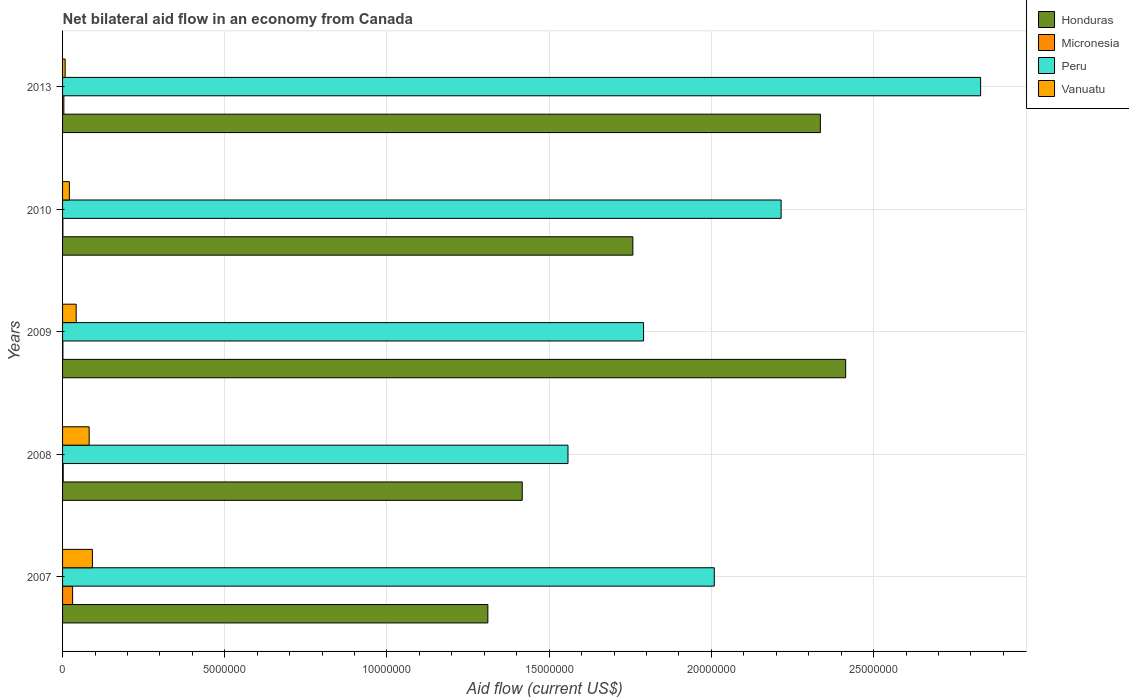How many groups of bars are there?
Ensure brevity in your answer.  5. Are the number of bars per tick equal to the number of legend labels?
Your response must be concise. Yes. Are the number of bars on each tick of the Y-axis equal?
Your answer should be compact. Yes. How many bars are there on the 5th tick from the top?
Your answer should be compact. 4. What is the label of the 2nd group of bars from the top?
Provide a succinct answer. 2010. In how many cases, is the number of bars for a given year not equal to the number of legend labels?
Provide a succinct answer. 0. What is the net bilateral aid flow in Vanuatu in 2008?
Your answer should be very brief. 8.20e+05. Across all years, what is the maximum net bilateral aid flow in Peru?
Your response must be concise. 2.83e+07. Across all years, what is the minimum net bilateral aid flow in Honduras?
Your answer should be compact. 1.31e+07. In which year was the net bilateral aid flow in Vanuatu maximum?
Keep it short and to the point. 2007. In which year was the net bilateral aid flow in Vanuatu minimum?
Provide a short and direct response. 2013. What is the total net bilateral aid flow in Micronesia in the graph?
Offer a terse response. 3.90e+05. What is the difference between the net bilateral aid flow in Honduras in 2007 and that in 2009?
Offer a very short reply. -1.10e+07. What is the difference between the net bilateral aid flow in Honduras in 2007 and the net bilateral aid flow in Peru in 2013?
Keep it short and to the point. -1.52e+07. What is the average net bilateral aid flow in Micronesia per year?
Your answer should be very brief. 7.80e+04. In the year 2010, what is the difference between the net bilateral aid flow in Honduras and net bilateral aid flow in Micronesia?
Your response must be concise. 1.76e+07. What is the ratio of the net bilateral aid flow in Honduras in 2007 to that in 2010?
Make the answer very short. 0.75. What is the difference between the highest and the second highest net bilateral aid flow in Honduras?
Keep it short and to the point. 7.80e+05. In how many years, is the net bilateral aid flow in Micronesia greater than the average net bilateral aid flow in Micronesia taken over all years?
Keep it short and to the point. 1. Is it the case that in every year, the sum of the net bilateral aid flow in Honduras and net bilateral aid flow in Micronesia is greater than the sum of net bilateral aid flow in Vanuatu and net bilateral aid flow in Peru?
Your answer should be compact. Yes. What does the 1st bar from the top in 2007 represents?
Keep it short and to the point. Vanuatu. What does the 4th bar from the bottom in 2008 represents?
Your answer should be compact. Vanuatu. How many bars are there?
Offer a terse response. 20. Are all the bars in the graph horizontal?
Offer a terse response. Yes. How many years are there in the graph?
Ensure brevity in your answer.  5. Does the graph contain grids?
Your answer should be very brief. Yes. Where does the legend appear in the graph?
Ensure brevity in your answer.  Top right. What is the title of the graph?
Make the answer very short. Net bilateral aid flow in an economy from Canada. What is the Aid flow (current US$) in Honduras in 2007?
Offer a very short reply. 1.31e+07. What is the Aid flow (current US$) in Peru in 2007?
Provide a short and direct response. 2.01e+07. What is the Aid flow (current US$) in Vanuatu in 2007?
Keep it short and to the point. 9.20e+05. What is the Aid flow (current US$) in Honduras in 2008?
Give a very brief answer. 1.42e+07. What is the Aid flow (current US$) of Micronesia in 2008?
Offer a very short reply. 2.00e+04. What is the Aid flow (current US$) of Peru in 2008?
Offer a very short reply. 1.56e+07. What is the Aid flow (current US$) of Vanuatu in 2008?
Keep it short and to the point. 8.20e+05. What is the Aid flow (current US$) of Honduras in 2009?
Offer a terse response. 2.41e+07. What is the Aid flow (current US$) in Peru in 2009?
Keep it short and to the point. 1.79e+07. What is the Aid flow (current US$) of Vanuatu in 2009?
Your response must be concise. 4.20e+05. What is the Aid flow (current US$) of Honduras in 2010?
Provide a succinct answer. 1.76e+07. What is the Aid flow (current US$) in Micronesia in 2010?
Keep it short and to the point. 10000. What is the Aid flow (current US$) in Peru in 2010?
Offer a very short reply. 2.22e+07. What is the Aid flow (current US$) of Vanuatu in 2010?
Provide a succinct answer. 2.10e+05. What is the Aid flow (current US$) in Honduras in 2013?
Offer a terse response. 2.34e+07. What is the Aid flow (current US$) in Peru in 2013?
Provide a succinct answer. 2.83e+07. Across all years, what is the maximum Aid flow (current US$) of Honduras?
Your answer should be compact. 2.41e+07. Across all years, what is the maximum Aid flow (current US$) of Micronesia?
Your response must be concise. 3.10e+05. Across all years, what is the maximum Aid flow (current US$) of Peru?
Your answer should be very brief. 2.83e+07. Across all years, what is the maximum Aid flow (current US$) of Vanuatu?
Make the answer very short. 9.20e+05. Across all years, what is the minimum Aid flow (current US$) of Honduras?
Provide a succinct answer. 1.31e+07. Across all years, what is the minimum Aid flow (current US$) of Micronesia?
Keep it short and to the point. 10000. Across all years, what is the minimum Aid flow (current US$) of Peru?
Offer a terse response. 1.56e+07. What is the total Aid flow (current US$) of Honduras in the graph?
Your response must be concise. 9.24e+07. What is the total Aid flow (current US$) of Micronesia in the graph?
Keep it short and to the point. 3.90e+05. What is the total Aid flow (current US$) in Peru in the graph?
Make the answer very short. 1.04e+08. What is the total Aid flow (current US$) in Vanuatu in the graph?
Provide a short and direct response. 2.45e+06. What is the difference between the Aid flow (current US$) of Honduras in 2007 and that in 2008?
Offer a terse response. -1.06e+06. What is the difference between the Aid flow (current US$) in Micronesia in 2007 and that in 2008?
Ensure brevity in your answer.  2.90e+05. What is the difference between the Aid flow (current US$) of Peru in 2007 and that in 2008?
Give a very brief answer. 4.51e+06. What is the difference between the Aid flow (current US$) in Honduras in 2007 and that in 2009?
Ensure brevity in your answer.  -1.10e+07. What is the difference between the Aid flow (current US$) in Peru in 2007 and that in 2009?
Offer a terse response. 2.18e+06. What is the difference between the Aid flow (current US$) in Honduras in 2007 and that in 2010?
Your answer should be compact. -4.47e+06. What is the difference between the Aid flow (current US$) of Micronesia in 2007 and that in 2010?
Give a very brief answer. 3.00e+05. What is the difference between the Aid flow (current US$) of Peru in 2007 and that in 2010?
Your response must be concise. -2.06e+06. What is the difference between the Aid flow (current US$) in Vanuatu in 2007 and that in 2010?
Ensure brevity in your answer.  7.10e+05. What is the difference between the Aid flow (current US$) of Honduras in 2007 and that in 2013?
Make the answer very short. -1.02e+07. What is the difference between the Aid flow (current US$) of Peru in 2007 and that in 2013?
Your response must be concise. -8.21e+06. What is the difference between the Aid flow (current US$) in Vanuatu in 2007 and that in 2013?
Your response must be concise. 8.40e+05. What is the difference between the Aid flow (current US$) in Honduras in 2008 and that in 2009?
Provide a short and direct response. -9.97e+06. What is the difference between the Aid flow (current US$) in Micronesia in 2008 and that in 2009?
Give a very brief answer. 10000. What is the difference between the Aid flow (current US$) of Peru in 2008 and that in 2009?
Give a very brief answer. -2.33e+06. What is the difference between the Aid flow (current US$) of Vanuatu in 2008 and that in 2009?
Make the answer very short. 4.00e+05. What is the difference between the Aid flow (current US$) in Honduras in 2008 and that in 2010?
Keep it short and to the point. -3.41e+06. What is the difference between the Aid flow (current US$) of Peru in 2008 and that in 2010?
Offer a terse response. -6.57e+06. What is the difference between the Aid flow (current US$) in Vanuatu in 2008 and that in 2010?
Provide a succinct answer. 6.10e+05. What is the difference between the Aid flow (current US$) of Honduras in 2008 and that in 2013?
Your answer should be compact. -9.19e+06. What is the difference between the Aid flow (current US$) in Micronesia in 2008 and that in 2013?
Ensure brevity in your answer.  -2.00e+04. What is the difference between the Aid flow (current US$) in Peru in 2008 and that in 2013?
Ensure brevity in your answer.  -1.27e+07. What is the difference between the Aid flow (current US$) in Vanuatu in 2008 and that in 2013?
Your answer should be very brief. 7.40e+05. What is the difference between the Aid flow (current US$) of Honduras in 2009 and that in 2010?
Your answer should be compact. 6.56e+06. What is the difference between the Aid flow (current US$) in Peru in 2009 and that in 2010?
Provide a short and direct response. -4.24e+06. What is the difference between the Aid flow (current US$) of Honduras in 2009 and that in 2013?
Keep it short and to the point. 7.80e+05. What is the difference between the Aid flow (current US$) of Peru in 2009 and that in 2013?
Offer a very short reply. -1.04e+07. What is the difference between the Aid flow (current US$) in Vanuatu in 2009 and that in 2013?
Offer a very short reply. 3.40e+05. What is the difference between the Aid flow (current US$) in Honduras in 2010 and that in 2013?
Your answer should be compact. -5.78e+06. What is the difference between the Aid flow (current US$) of Micronesia in 2010 and that in 2013?
Provide a succinct answer. -3.00e+04. What is the difference between the Aid flow (current US$) in Peru in 2010 and that in 2013?
Give a very brief answer. -6.15e+06. What is the difference between the Aid flow (current US$) of Vanuatu in 2010 and that in 2013?
Your answer should be compact. 1.30e+05. What is the difference between the Aid flow (current US$) of Honduras in 2007 and the Aid flow (current US$) of Micronesia in 2008?
Ensure brevity in your answer.  1.31e+07. What is the difference between the Aid flow (current US$) of Honduras in 2007 and the Aid flow (current US$) of Peru in 2008?
Make the answer very short. -2.47e+06. What is the difference between the Aid flow (current US$) in Honduras in 2007 and the Aid flow (current US$) in Vanuatu in 2008?
Give a very brief answer. 1.23e+07. What is the difference between the Aid flow (current US$) of Micronesia in 2007 and the Aid flow (current US$) of Peru in 2008?
Give a very brief answer. -1.53e+07. What is the difference between the Aid flow (current US$) of Micronesia in 2007 and the Aid flow (current US$) of Vanuatu in 2008?
Your response must be concise. -5.10e+05. What is the difference between the Aid flow (current US$) of Peru in 2007 and the Aid flow (current US$) of Vanuatu in 2008?
Offer a very short reply. 1.93e+07. What is the difference between the Aid flow (current US$) of Honduras in 2007 and the Aid flow (current US$) of Micronesia in 2009?
Offer a terse response. 1.31e+07. What is the difference between the Aid flow (current US$) in Honduras in 2007 and the Aid flow (current US$) in Peru in 2009?
Provide a succinct answer. -4.80e+06. What is the difference between the Aid flow (current US$) of Honduras in 2007 and the Aid flow (current US$) of Vanuatu in 2009?
Keep it short and to the point. 1.27e+07. What is the difference between the Aid flow (current US$) of Micronesia in 2007 and the Aid flow (current US$) of Peru in 2009?
Make the answer very short. -1.76e+07. What is the difference between the Aid flow (current US$) of Micronesia in 2007 and the Aid flow (current US$) of Vanuatu in 2009?
Make the answer very short. -1.10e+05. What is the difference between the Aid flow (current US$) of Peru in 2007 and the Aid flow (current US$) of Vanuatu in 2009?
Give a very brief answer. 1.97e+07. What is the difference between the Aid flow (current US$) of Honduras in 2007 and the Aid flow (current US$) of Micronesia in 2010?
Provide a succinct answer. 1.31e+07. What is the difference between the Aid flow (current US$) of Honduras in 2007 and the Aid flow (current US$) of Peru in 2010?
Offer a terse response. -9.04e+06. What is the difference between the Aid flow (current US$) of Honduras in 2007 and the Aid flow (current US$) of Vanuatu in 2010?
Your answer should be compact. 1.29e+07. What is the difference between the Aid flow (current US$) of Micronesia in 2007 and the Aid flow (current US$) of Peru in 2010?
Make the answer very short. -2.18e+07. What is the difference between the Aid flow (current US$) in Peru in 2007 and the Aid flow (current US$) in Vanuatu in 2010?
Provide a short and direct response. 1.99e+07. What is the difference between the Aid flow (current US$) of Honduras in 2007 and the Aid flow (current US$) of Micronesia in 2013?
Offer a very short reply. 1.31e+07. What is the difference between the Aid flow (current US$) in Honduras in 2007 and the Aid flow (current US$) in Peru in 2013?
Offer a very short reply. -1.52e+07. What is the difference between the Aid flow (current US$) of Honduras in 2007 and the Aid flow (current US$) of Vanuatu in 2013?
Your answer should be compact. 1.30e+07. What is the difference between the Aid flow (current US$) in Micronesia in 2007 and the Aid flow (current US$) in Peru in 2013?
Make the answer very short. -2.80e+07. What is the difference between the Aid flow (current US$) of Micronesia in 2007 and the Aid flow (current US$) of Vanuatu in 2013?
Keep it short and to the point. 2.30e+05. What is the difference between the Aid flow (current US$) of Peru in 2007 and the Aid flow (current US$) of Vanuatu in 2013?
Ensure brevity in your answer.  2.00e+07. What is the difference between the Aid flow (current US$) of Honduras in 2008 and the Aid flow (current US$) of Micronesia in 2009?
Offer a terse response. 1.42e+07. What is the difference between the Aid flow (current US$) of Honduras in 2008 and the Aid flow (current US$) of Peru in 2009?
Keep it short and to the point. -3.74e+06. What is the difference between the Aid flow (current US$) of Honduras in 2008 and the Aid flow (current US$) of Vanuatu in 2009?
Give a very brief answer. 1.38e+07. What is the difference between the Aid flow (current US$) of Micronesia in 2008 and the Aid flow (current US$) of Peru in 2009?
Give a very brief answer. -1.79e+07. What is the difference between the Aid flow (current US$) in Micronesia in 2008 and the Aid flow (current US$) in Vanuatu in 2009?
Provide a short and direct response. -4.00e+05. What is the difference between the Aid flow (current US$) of Peru in 2008 and the Aid flow (current US$) of Vanuatu in 2009?
Keep it short and to the point. 1.52e+07. What is the difference between the Aid flow (current US$) in Honduras in 2008 and the Aid flow (current US$) in Micronesia in 2010?
Your answer should be very brief. 1.42e+07. What is the difference between the Aid flow (current US$) in Honduras in 2008 and the Aid flow (current US$) in Peru in 2010?
Your answer should be very brief. -7.98e+06. What is the difference between the Aid flow (current US$) in Honduras in 2008 and the Aid flow (current US$) in Vanuatu in 2010?
Your answer should be compact. 1.40e+07. What is the difference between the Aid flow (current US$) of Micronesia in 2008 and the Aid flow (current US$) of Peru in 2010?
Provide a succinct answer. -2.21e+07. What is the difference between the Aid flow (current US$) in Micronesia in 2008 and the Aid flow (current US$) in Vanuatu in 2010?
Offer a very short reply. -1.90e+05. What is the difference between the Aid flow (current US$) of Peru in 2008 and the Aid flow (current US$) of Vanuatu in 2010?
Your answer should be compact. 1.54e+07. What is the difference between the Aid flow (current US$) of Honduras in 2008 and the Aid flow (current US$) of Micronesia in 2013?
Provide a succinct answer. 1.41e+07. What is the difference between the Aid flow (current US$) of Honduras in 2008 and the Aid flow (current US$) of Peru in 2013?
Keep it short and to the point. -1.41e+07. What is the difference between the Aid flow (current US$) in Honduras in 2008 and the Aid flow (current US$) in Vanuatu in 2013?
Your response must be concise. 1.41e+07. What is the difference between the Aid flow (current US$) in Micronesia in 2008 and the Aid flow (current US$) in Peru in 2013?
Your answer should be compact. -2.83e+07. What is the difference between the Aid flow (current US$) of Peru in 2008 and the Aid flow (current US$) of Vanuatu in 2013?
Keep it short and to the point. 1.55e+07. What is the difference between the Aid flow (current US$) of Honduras in 2009 and the Aid flow (current US$) of Micronesia in 2010?
Offer a very short reply. 2.41e+07. What is the difference between the Aid flow (current US$) of Honduras in 2009 and the Aid flow (current US$) of Peru in 2010?
Your answer should be compact. 1.99e+06. What is the difference between the Aid flow (current US$) in Honduras in 2009 and the Aid flow (current US$) in Vanuatu in 2010?
Your answer should be very brief. 2.39e+07. What is the difference between the Aid flow (current US$) of Micronesia in 2009 and the Aid flow (current US$) of Peru in 2010?
Your answer should be compact. -2.21e+07. What is the difference between the Aid flow (current US$) of Micronesia in 2009 and the Aid flow (current US$) of Vanuatu in 2010?
Offer a terse response. -2.00e+05. What is the difference between the Aid flow (current US$) in Peru in 2009 and the Aid flow (current US$) in Vanuatu in 2010?
Provide a succinct answer. 1.77e+07. What is the difference between the Aid flow (current US$) of Honduras in 2009 and the Aid flow (current US$) of Micronesia in 2013?
Provide a succinct answer. 2.41e+07. What is the difference between the Aid flow (current US$) of Honduras in 2009 and the Aid flow (current US$) of Peru in 2013?
Offer a very short reply. -4.16e+06. What is the difference between the Aid flow (current US$) in Honduras in 2009 and the Aid flow (current US$) in Vanuatu in 2013?
Offer a very short reply. 2.41e+07. What is the difference between the Aid flow (current US$) in Micronesia in 2009 and the Aid flow (current US$) in Peru in 2013?
Your response must be concise. -2.83e+07. What is the difference between the Aid flow (current US$) of Micronesia in 2009 and the Aid flow (current US$) of Vanuatu in 2013?
Offer a very short reply. -7.00e+04. What is the difference between the Aid flow (current US$) of Peru in 2009 and the Aid flow (current US$) of Vanuatu in 2013?
Give a very brief answer. 1.78e+07. What is the difference between the Aid flow (current US$) in Honduras in 2010 and the Aid flow (current US$) in Micronesia in 2013?
Your answer should be very brief. 1.75e+07. What is the difference between the Aid flow (current US$) in Honduras in 2010 and the Aid flow (current US$) in Peru in 2013?
Make the answer very short. -1.07e+07. What is the difference between the Aid flow (current US$) in Honduras in 2010 and the Aid flow (current US$) in Vanuatu in 2013?
Offer a very short reply. 1.75e+07. What is the difference between the Aid flow (current US$) in Micronesia in 2010 and the Aid flow (current US$) in Peru in 2013?
Offer a terse response. -2.83e+07. What is the difference between the Aid flow (current US$) of Peru in 2010 and the Aid flow (current US$) of Vanuatu in 2013?
Keep it short and to the point. 2.21e+07. What is the average Aid flow (current US$) in Honduras per year?
Ensure brevity in your answer.  1.85e+07. What is the average Aid flow (current US$) of Micronesia per year?
Your answer should be very brief. 7.80e+04. What is the average Aid flow (current US$) of Peru per year?
Make the answer very short. 2.08e+07. What is the average Aid flow (current US$) of Vanuatu per year?
Your answer should be very brief. 4.90e+05. In the year 2007, what is the difference between the Aid flow (current US$) in Honduras and Aid flow (current US$) in Micronesia?
Give a very brief answer. 1.28e+07. In the year 2007, what is the difference between the Aid flow (current US$) in Honduras and Aid flow (current US$) in Peru?
Offer a very short reply. -6.98e+06. In the year 2007, what is the difference between the Aid flow (current US$) in Honduras and Aid flow (current US$) in Vanuatu?
Give a very brief answer. 1.22e+07. In the year 2007, what is the difference between the Aid flow (current US$) in Micronesia and Aid flow (current US$) in Peru?
Make the answer very short. -1.98e+07. In the year 2007, what is the difference between the Aid flow (current US$) of Micronesia and Aid flow (current US$) of Vanuatu?
Make the answer very short. -6.10e+05. In the year 2007, what is the difference between the Aid flow (current US$) in Peru and Aid flow (current US$) in Vanuatu?
Your answer should be very brief. 1.92e+07. In the year 2008, what is the difference between the Aid flow (current US$) of Honduras and Aid flow (current US$) of Micronesia?
Your answer should be very brief. 1.42e+07. In the year 2008, what is the difference between the Aid flow (current US$) in Honduras and Aid flow (current US$) in Peru?
Make the answer very short. -1.41e+06. In the year 2008, what is the difference between the Aid flow (current US$) in Honduras and Aid flow (current US$) in Vanuatu?
Offer a very short reply. 1.34e+07. In the year 2008, what is the difference between the Aid flow (current US$) of Micronesia and Aid flow (current US$) of Peru?
Offer a terse response. -1.56e+07. In the year 2008, what is the difference between the Aid flow (current US$) of Micronesia and Aid flow (current US$) of Vanuatu?
Provide a short and direct response. -8.00e+05. In the year 2008, what is the difference between the Aid flow (current US$) in Peru and Aid flow (current US$) in Vanuatu?
Offer a terse response. 1.48e+07. In the year 2009, what is the difference between the Aid flow (current US$) of Honduras and Aid flow (current US$) of Micronesia?
Give a very brief answer. 2.41e+07. In the year 2009, what is the difference between the Aid flow (current US$) of Honduras and Aid flow (current US$) of Peru?
Your answer should be very brief. 6.23e+06. In the year 2009, what is the difference between the Aid flow (current US$) in Honduras and Aid flow (current US$) in Vanuatu?
Offer a terse response. 2.37e+07. In the year 2009, what is the difference between the Aid flow (current US$) in Micronesia and Aid flow (current US$) in Peru?
Provide a short and direct response. -1.79e+07. In the year 2009, what is the difference between the Aid flow (current US$) in Micronesia and Aid flow (current US$) in Vanuatu?
Offer a terse response. -4.10e+05. In the year 2009, what is the difference between the Aid flow (current US$) in Peru and Aid flow (current US$) in Vanuatu?
Provide a short and direct response. 1.75e+07. In the year 2010, what is the difference between the Aid flow (current US$) in Honduras and Aid flow (current US$) in Micronesia?
Give a very brief answer. 1.76e+07. In the year 2010, what is the difference between the Aid flow (current US$) in Honduras and Aid flow (current US$) in Peru?
Make the answer very short. -4.57e+06. In the year 2010, what is the difference between the Aid flow (current US$) in Honduras and Aid flow (current US$) in Vanuatu?
Provide a succinct answer. 1.74e+07. In the year 2010, what is the difference between the Aid flow (current US$) in Micronesia and Aid flow (current US$) in Peru?
Offer a terse response. -2.21e+07. In the year 2010, what is the difference between the Aid flow (current US$) in Micronesia and Aid flow (current US$) in Vanuatu?
Your response must be concise. -2.00e+05. In the year 2010, what is the difference between the Aid flow (current US$) of Peru and Aid flow (current US$) of Vanuatu?
Offer a terse response. 2.19e+07. In the year 2013, what is the difference between the Aid flow (current US$) of Honduras and Aid flow (current US$) of Micronesia?
Give a very brief answer. 2.33e+07. In the year 2013, what is the difference between the Aid flow (current US$) of Honduras and Aid flow (current US$) of Peru?
Ensure brevity in your answer.  -4.94e+06. In the year 2013, what is the difference between the Aid flow (current US$) of Honduras and Aid flow (current US$) of Vanuatu?
Your answer should be very brief. 2.33e+07. In the year 2013, what is the difference between the Aid flow (current US$) of Micronesia and Aid flow (current US$) of Peru?
Offer a terse response. -2.83e+07. In the year 2013, what is the difference between the Aid flow (current US$) of Micronesia and Aid flow (current US$) of Vanuatu?
Ensure brevity in your answer.  -4.00e+04. In the year 2013, what is the difference between the Aid flow (current US$) in Peru and Aid flow (current US$) in Vanuatu?
Your answer should be compact. 2.82e+07. What is the ratio of the Aid flow (current US$) of Honduras in 2007 to that in 2008?
Offer a terse response. 0.93. What is the ratio of the Aid flow (current US$) in Micronesia in 2007 to that in 2008?
Ensure brevity in your answer.  15.5. What is the ratio of the Aid flow (current US$) in Peru in 2007 to that in 2008?
Ensure brevity in your answer.  1.29. What is the ratio of the Aid flow (current US$) in Vanuatu in 2007 to that in 2008?
Give a very brief answer. 1.12. What is the ratio of the Aid flow (current US$) of Honduras in 2007 to that in 2009?
Provide a succinct answer. 0.54. What is the ratio of the Aid flow (current US$) of Peru in 2007 to that in 2009?
Offer a very short reply. 1.12. What is the ratio of the Aid flow (current US$) of Vanuatu in 2007 to that in 2009?
Your response must be concise. 2.19. What is the ratio of the Aid flow (current US$) of Honduras in 2007 to that in 2010?
Provide a short and direct response. 0.75. What is the ratio of the Aid flow (current US$) of Peru in 2007 to that in 2010?
Offer a very short reply. 0.91. What is the ratio of the Aid flow (current US$) of Vanuatu in 2007 to that in 2010?
Make the answer very short. 4.38. What is the ratio of the Aid flow (current US$) in Honduras in 2007 to that in 2013?
Offer a terse response. 0.56. What is the ratio of the Aid flow (current US$) of Micronesia in 2007 to that in 2013?
Your response must be concise. 7.75. What is the ratio of the Aid flow (current US$) of Peru in 2007 to that in 2013?
Offer a terse response. 0.71. What is the ratio of the Aid flow (current US$) in Honduras in 2008 to that in 2009?
Give a very brief answer. 0.59. What is the ratio of the Aid flow (current US$) of Micronesia in 2008 to that in 2009?
Make the answer very short. 2. What is the ratio of the Aid flow (current US$) in Peru in 2008 to that in 2009?
Provide a short and direct response. 0.87. What is the ratio of the Aid flow (current US$) in Vanuatu in 2008 to that in 2009?
Offer a very short reply. 1.95. What is the ratio of the Aid flow (current US$) of Honduras in 2008 to that in 2010?
Offer a very short reply. 0.81. What is the ratio of the Aid flow (current US$) of Micronesia in 2008 to that in 2010?
Give a very brief answer. 2. What is the ratio of the Aid flow (current US$) of Peru in 2008 to that in 2010?
Your response must be concise. 0.7. What is the ratio of the Aid flow (current US$) in Vanuatu in 2008 to that in 2010?
Your response must be concise. 3.9. What is the ratio of the Aid flow (current US$) of Honduras in 2008 to that in 2013?
Your answer should be very brief. 0.61. What is the ratio of the Aid flow (current US$) in Micronesia in 2008 to that in 2013?
Your response must be concise. 0.5. What is the ratio of the Aid flow (current US$) of Peru in 2008 to that in 2013?
Your answer should be compact. 0.55. What is the ratio of the Aid flow (current US$) in Vanuatu in 2008 to that in 2013?
Make the answer very short. 10.25. What is the ratio of the Aid flow (current US$) in Honduras in 2009 to that in 2010?
Offer a terse response. 1.37. What is the ratio of the Aid flow (current US$) of Peru in 2009 to that in 2010?
Your answer should be very brief. 0.81. What is the ratio of the Aid flow (current US$) of Honduras in 2009 to that in 2013?
Provide a succinct answer. 1.03. What is the ratio of the Aid flow (current US$) of Micronesia in 2009 to that in 2013?
Offer a very short reply. 0.25. What is the ratio of the Aid flow (current US$) in Peru in 2009 to that in 2013?
Keep it short and to the point. 0.63. What is the ratio of the Aid flow (current US$) in Vanuatu in 2009 to that in 2013?
Provide a succinct answer. 5.25. What is the ratio of the Aid flow (current US$) of Honduras in 2010 to that in 2013?
Your response must be concise. 0.75. What is the ratio of the Aid flow (current US$) of Micronesia in 2010 to that in 2013?
Keep it short and to the point. 0.25. What is the ratio of the Aid flow (current US$) in Peru in 2010 to that in 2013?
Provide a short and direct response. 0.78. What is the ratio of the Aid flow (current US$) of Vanuatu in 2010 to that in 2013?
Your answer should be very brief. 2.62. What is the difference between the highest and the second highest Aid flow (current US$) of Honduras?
Your answer should be compact. 7.80e+05. What is the difference between the highest and the second highest Aid flow (current US$) of Peru?
Make the answer very short. 6.15e+06. What is the difference between the highest and the lowest Aid flow (current US$) of Honduras?
Offer a very short reply. 1.10e+07. What is the difference between the highest and the lowest Aid flow (current US$) in Peru?
Give a very brief answer. 1.27e+07. What is the difference between the highest and the lowest Aid flow (current US$) of Vanuatu?
Give a very brief answer. 8.40e+05. 